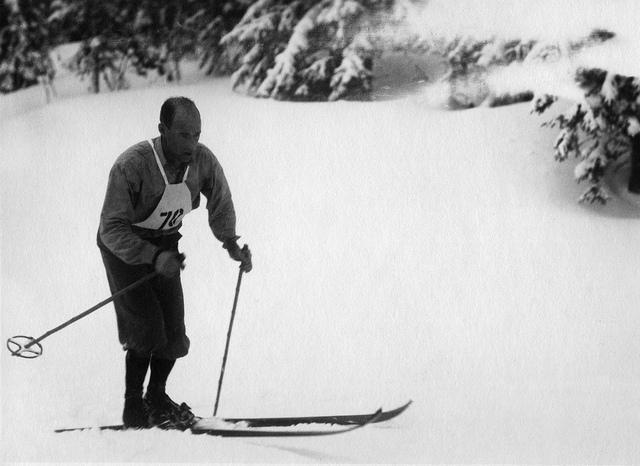How many train cars are on the right of the man ?
Give a very brief answer. 0. 